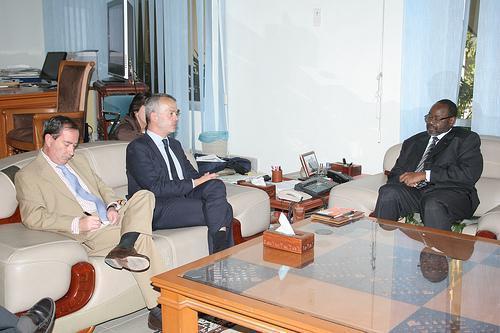How many men are sitting on the left couch?
Give a very brief answer. 2. 